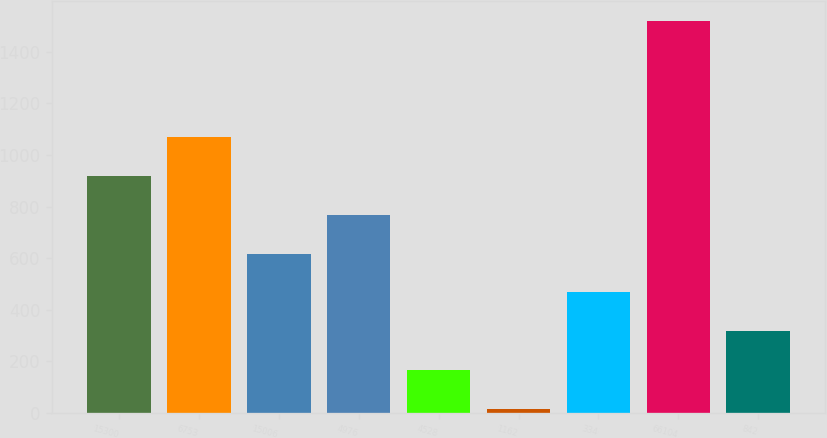Convert chart. <chart><loc_0><loc_0><loc_500><loc_500><bar_chart><fcel>15300<fcel>6753<fcel>15006<fcel>4976<fcel>4528<fcel>1162<fcel>334<fcel>66104<fcel>842<nl><fcel>917.8<fcel>1068.1<fcel>617.2<fcel>767.5<fcel>166.3<fcel>16<fcel>466.9<fcel>1519<fcel>316.6<nl></chart> 